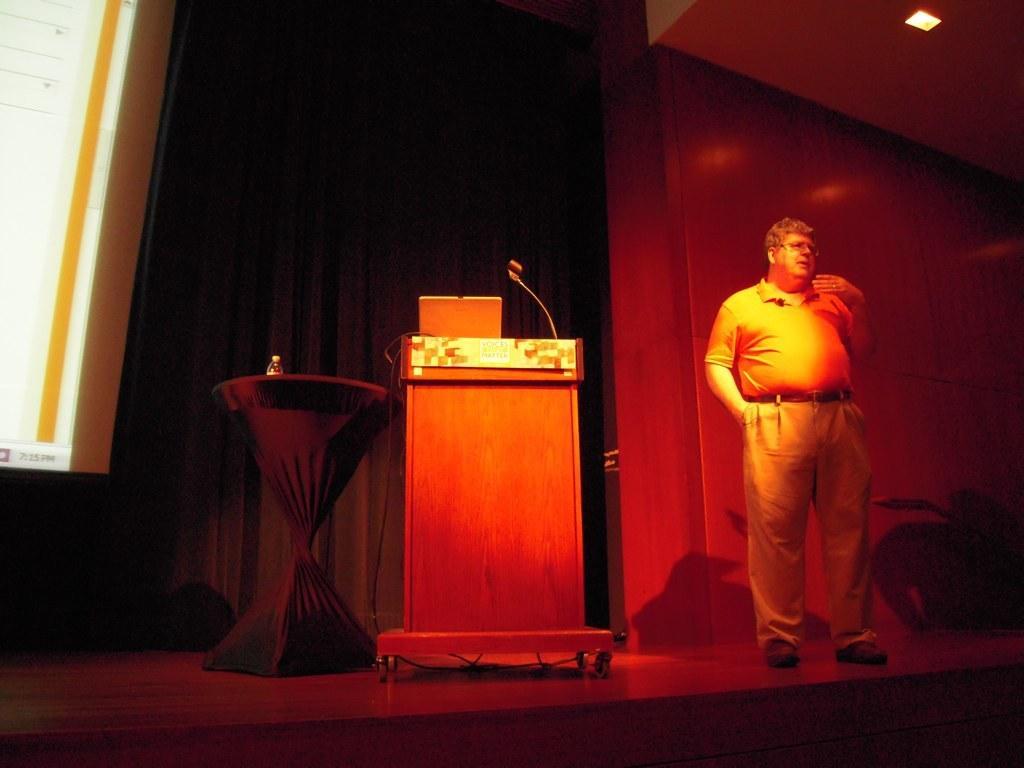Please provide a concise description of this image. In the picture we can see a man standing on the stage and talking and beside him we can see a microphone desk with a microphone on it and beside it, we can see a round table on it, we can see a water bottle and behind it we can see a wall with black color curtains and to the ceiling we can see a light. 